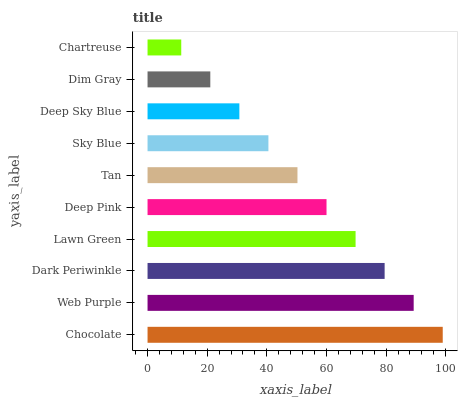Is Chartreuse the minimum?
Answer yes or no. Yes. Is Chocolate the maximum?
Answer yes or no. Yes. Is Web Purple the minimum?
Answer yes or no. No. Is Web Purple the maximum?
Answer yes or no. No. Is Chocolate greater than Web Purple?
Answer yes or no. Yes. Is Web Purple less than Chocolate?
Answer yes or no. Yes. Is Web Purple greater than Chocolate?
Answer yes or no. No. Is Chocolate less than Web Purple?
Answer yes or no. No. Is Deep Pink the high median?
Answer yes or no. Yes. Is Tan the low median?
Answer yes or no. Yes. Is Tan the high median?
Answer yes or no. No. Is Deep Sky Blue the low median?
Answer yes or no. No. 